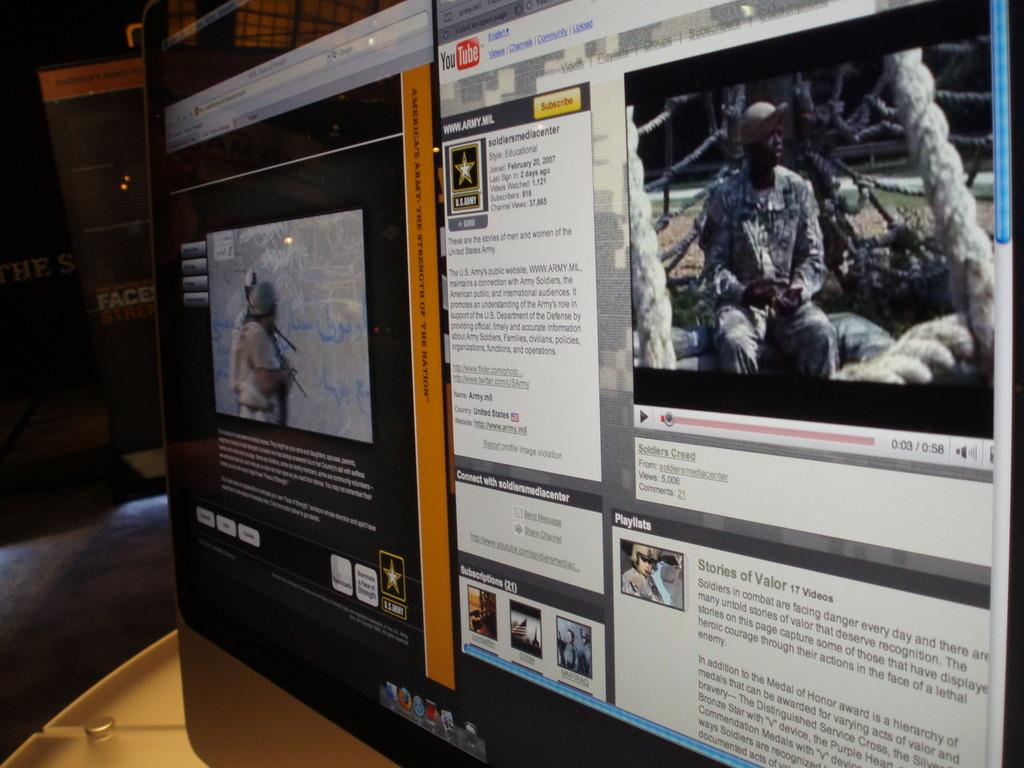<image>
Describe the image concisely. a YouTube icon in the top left of the screen 